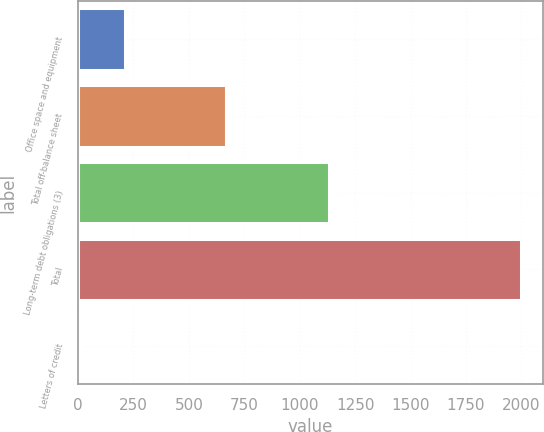Convert chart. <chart><loc_0><loc_0><loc_500><loc_500><bar_chart><fcel>Office space and equipment<fcel>Total off-balance sheet<fcel>Long-term debt obligations (3)<fcel>Total<fcel>Letters of credit<nl><fcel>211.08<fcel>666.8<fcel>1133.1<fcel>1997.4<fcel>12.6<nl></chart> 